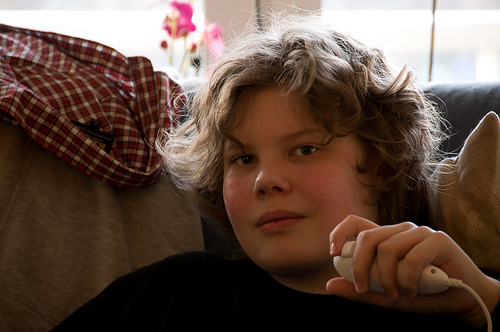<image>Why is the girl smiling? It is unknown why the girl is smiling. She could be happy or posing for a picture. Why is the girl smiling? It is unknown why the girl is smiling. She could be happy, posing for a picture or playing a game. 